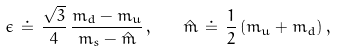<formula> <loc_0><loc_0><loc_500><loc_500>\epsilon \, \doteq \, \frac { \sqrt { 3 } } { 4 } \, \frac { m _ { d } - m _ { u } } { m _ { s } - \hat { m } } \, , \quad \hat { m } \, \doteq \, \frac { 1 } { 2 } \, ( m _ { u } + m _ { d } ) \, ,</formula> 